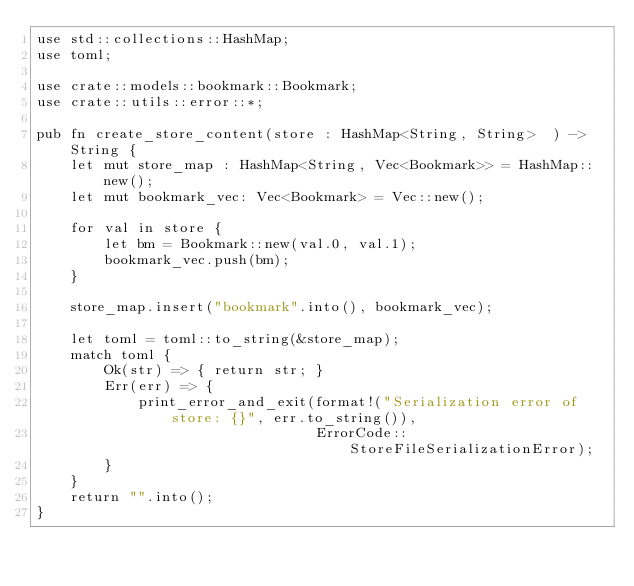Convert code to text. <code><loc_0><loc_0><loc_500><loc_500><_Rust_>use std::collections::HashMap;
use toml;

use crate::models::bookmark::Bookmark;
use crate::utils::error::*;

pub fn create_store_content(store : HashMap<String, String>  ) -> String {
    let mut store_map : HashMap<String, Vec<Bookmark>> = HashMap::new();
    let mut bookmark_vec: Vec<Bookmark> = Vec::new();

    for val in store {
        let bm = Bookmark::new(val.0, val.1);
        bookmark_vec.push(bm);
    }

    store_map.insert("bookmark".into(), bookmark_vec);

    let toml = toml::to_string(&store_map);
    match toml {
        Ok(str) => { return str; }
        Err(err) => {
            print_error_and_exit(format!("Serialization error of store: {}", err.to_string()),
                                 ErrorCode::StoreFileSerializationError);
        }
    }
    return "".into();
}</code> 